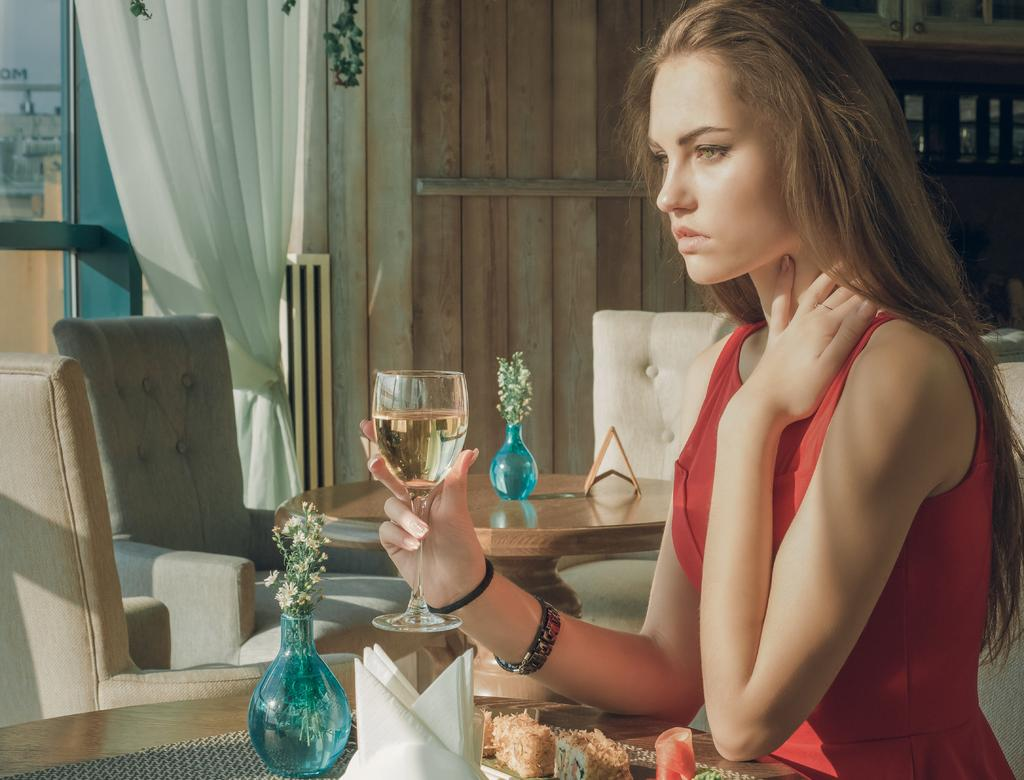What is the woman in the image doing? The woman is sitting in the image. What is the woman holding in the image? The woman is holding a glass in the image. What piece of furniture is present in the image? There is a table in the image. What type of seating is visible in the image? There are sofas in the image. What type of window treatment is present in the image? There is a curtain in the image. What architectural feature is visible in the image? There is a window in the image. What type of egg can be seen on the table in the image? There is no egg present on the table in the image. What type of knife is the woman using to cut the curtain in the image? There is no knife or curtain-cutting activity present in the image. 